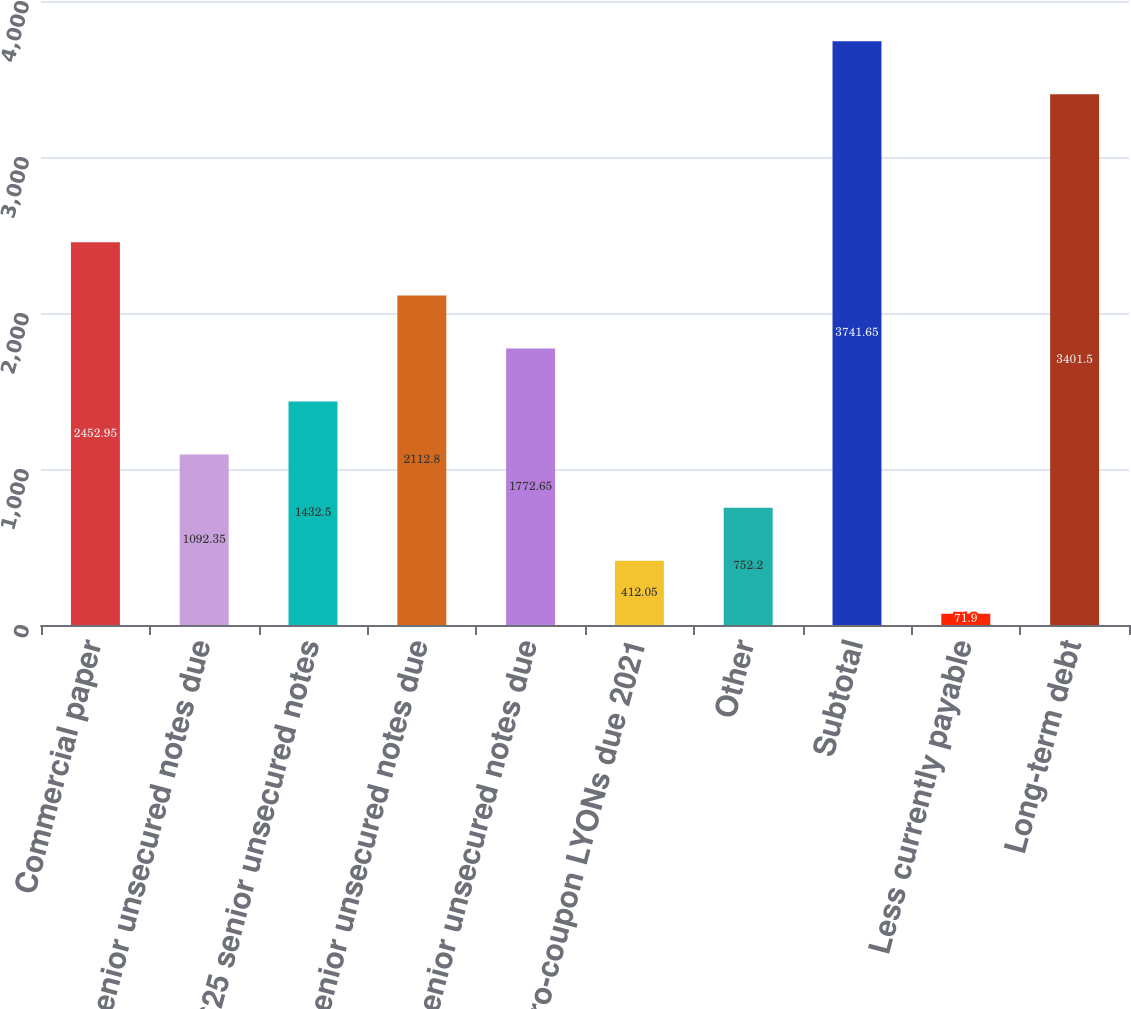Convert chart to OTSL. <chart><loc_0><loc_0><loc_500><loc_500><bar_chart><fcel>Commercial paper<fcel>23 senior unsecured notes due<fcel>5625 senior unsecured notes<fcel>54 senior unsecured notes due<fcel>39 senior unsecured notes due<fcel>Zero-coupon LYONs due 2021<fcel>Other<fcel>Subtotal<fcel>Less currently payable<fcel>Long-term debt<nl><fcel>2452.95<fcel>1092.35<fcel>1432.5<fcel>2112.8<fcel>1772.65<fcel>412.05<fcel>752.2<fcel>3741.65<fcel>71.9<fcel>3401.5<nl></chart> 